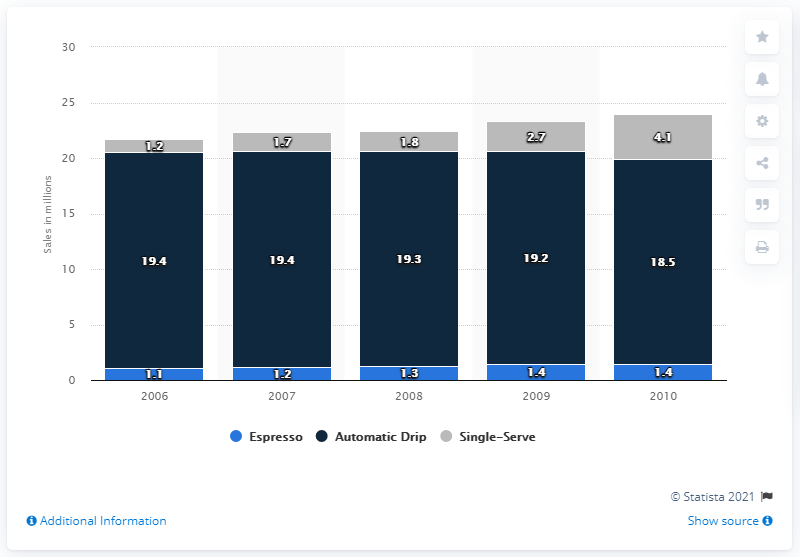Draw attention to some important aspects in this diagram. In 2010, approximately 1.4 million espresso machines were sold in the United States. 